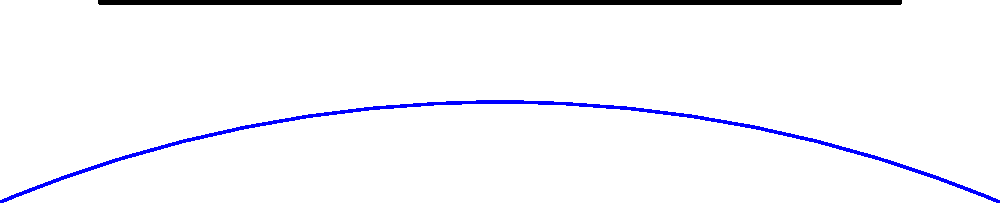Analyze the layout of this typical Yarmouth, Maine colonial village. Which key feature is centrally located and likely served as a focal point for community gatherings and activities? To answer this question, let's analyze the layout of the colonial village step-by-step:

1. Coastline: The bottom of the image shows a blue curved line representing the coastline, typical of Yarmouth's location on the coast of Maine.

2. Main Street: A prominent straight line runs horizontally across the center of the image, labeled "Main Street". This was often the primary thoroughfare in colonial towns.

3. Houses: Several small rectangular structures are lined up along Main Street, representing the residential buildings of the village.

4. Church: A larger red rectangular structure is located towards the top of the image, labeled "Church". The church was often a significant building in colonial towns.

5. Town Green: In the center of the image, there's a circular green area labeled "Town Green".

The key feature that is centrally located and likely served as a focal point for community gatherings and activities is the Town Green. In colonial New England towns, the town green was typically a central, open space used for:

- Public gatherings
- Town meetings
- Military drills
- Grazing livestock
- Markets and fairs

Its central location in this layout, surrounded by the main street, houses, and near the church, indicates its importance as a community focal point in the village structure.
Answer: The Town Green 